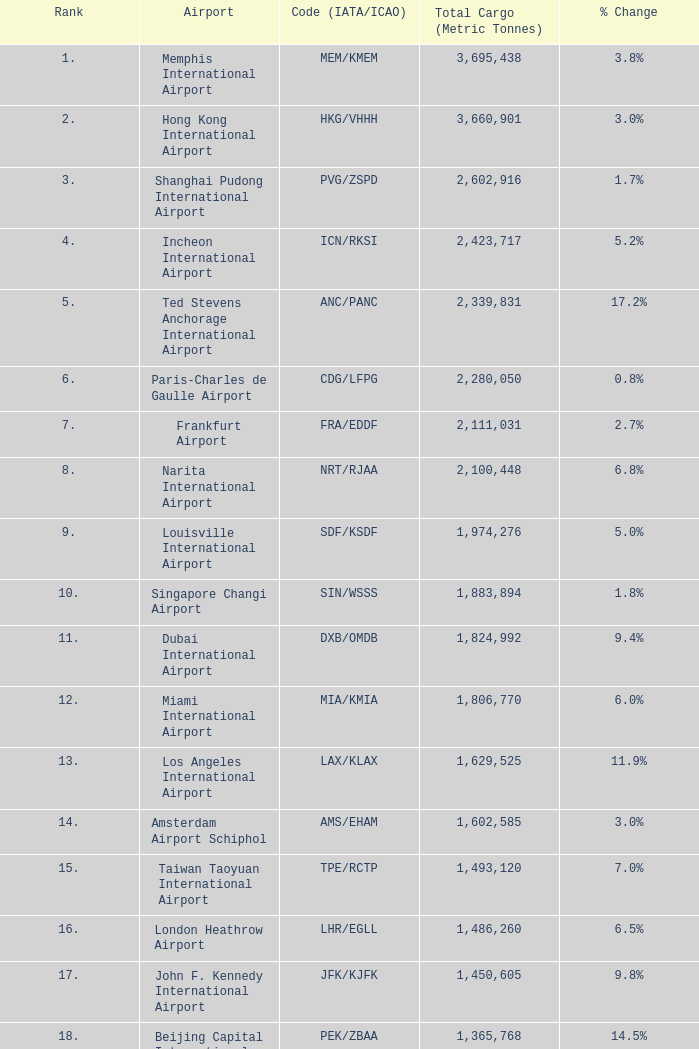What is the position for ord/kord with over 1,332,123 total freight? None. 